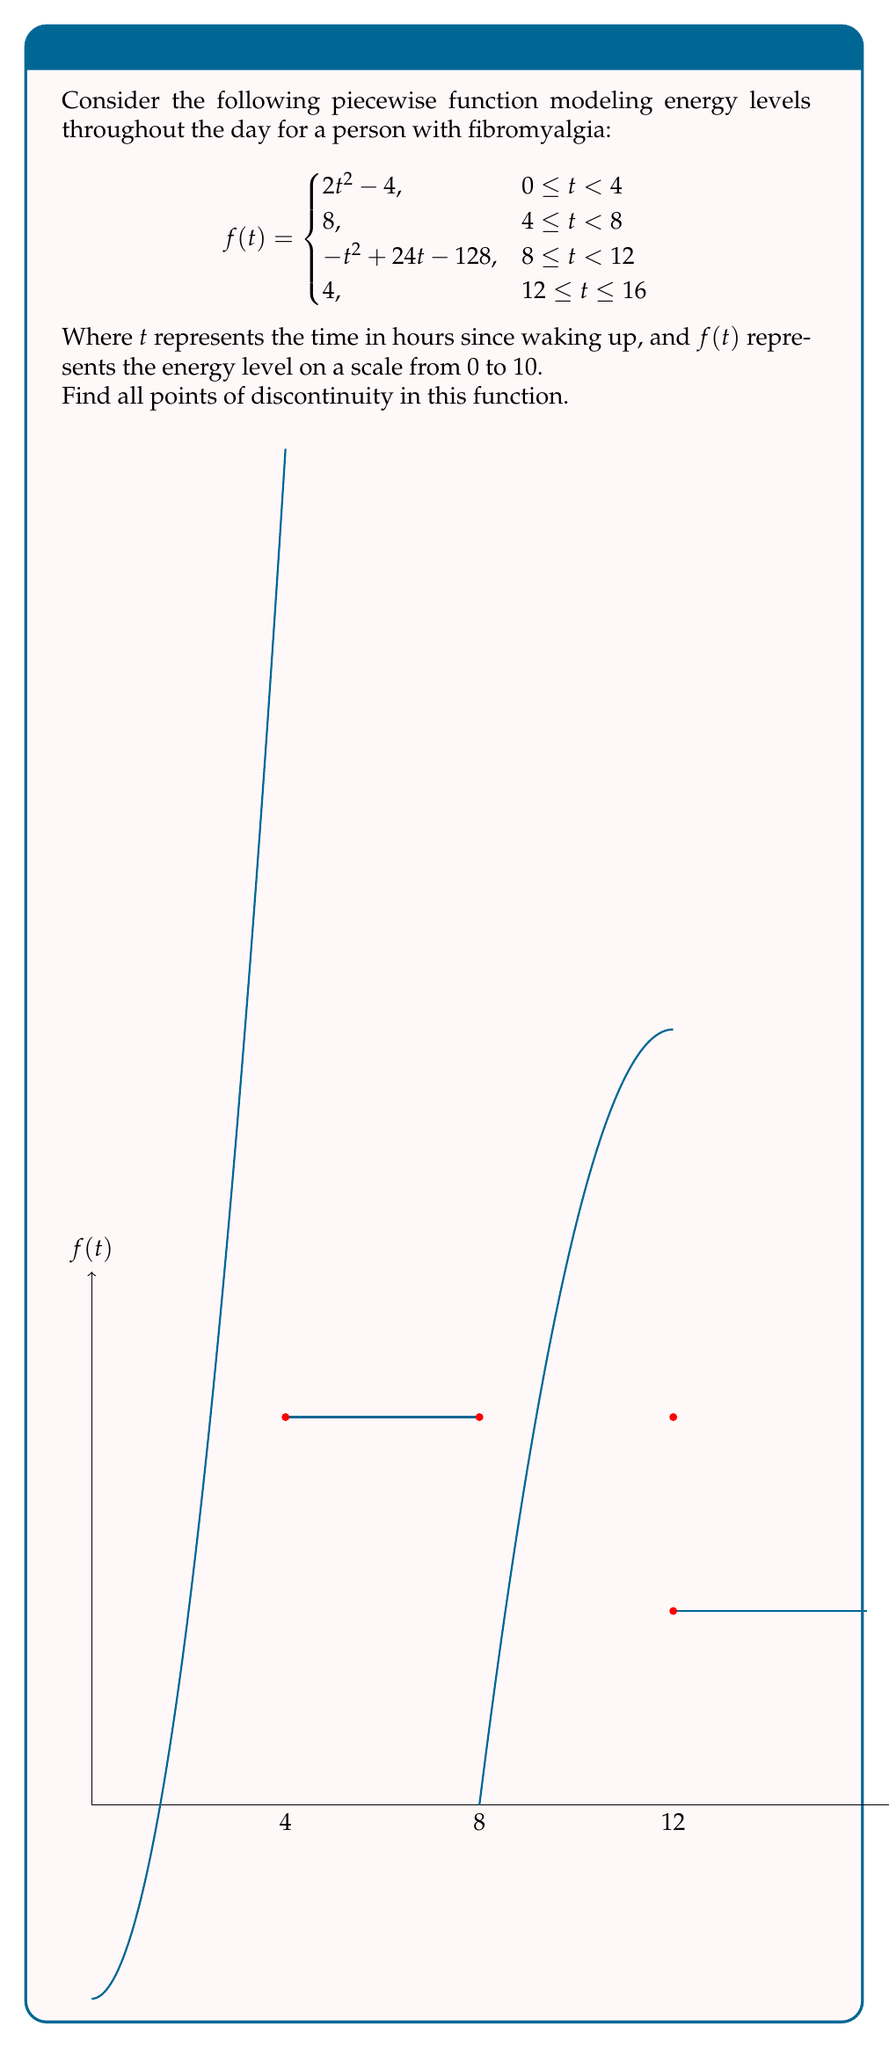Can you solve this math problem? To find the points of discontinuity, we need to check for three types of continuity at each transition point:

1. Left-hand limit exists
2. Right-hand limit exists
3. Both limits are equal to the function value at that point

Let's check each transition point:

1. At $t = 4$:
   Left limit: $\lim_{t \to 4^-} (2t^2 - 4) = 2(4)^2 - 4 = 28$
   Right limit: $\lim_{t \to 4^+} 8 = 8$
   Function value: $f(4) = 8$
   The left limit ≠ right limit, so there's a discontinuity at $t = 4$.

2. At $t = 8$:
   Left limit: $\lim_{t \to 8^-} 8 = 8$
   Right limit: $\lim_{t \to 8^+} (-t^2 + 24t - 128) = -8^2 + 24(8) - 128 = 8$
   Function value: $f(8) = 8$
   All three values are equal, so the function is continuous at $t = 8$.

3. At $t = 12$:
   Left limit: $\lim_{t \to 12^-} (-t^2 + 24t - 128) = -12^2 + 24(12) - 128 = 16$
   Right limit: $\lim_{t \to 12^+} 4 = 4$
   Function value: $f(12) = 4$
   The left limit ≠ right limit, so there's a discontinuity at $t = 12$.

Therefore, the function has discontinuities at $t = 4$ and $t = 12$.
Answer: $t = 4$ and $t = 12$ 